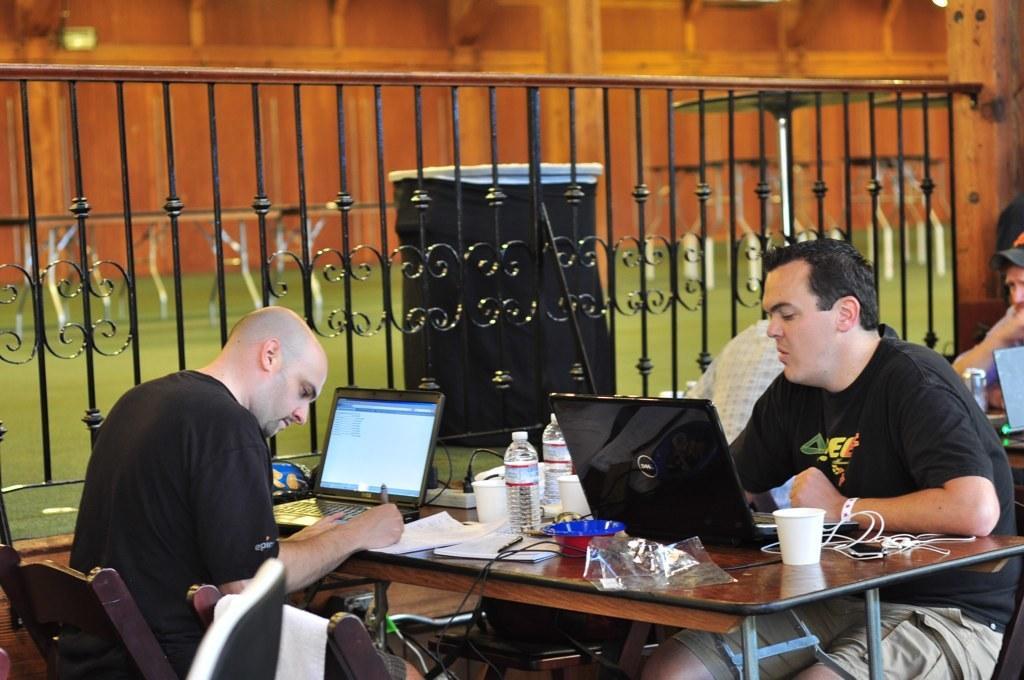Can you describe this image briefly? These two persons are sitting on a chair. In-front of them there is a table. On this table there are laptops, bottles, mobile, bowl, book, cups and cables. This person is writing on a paper. Beside this people there is a fence in black color. 